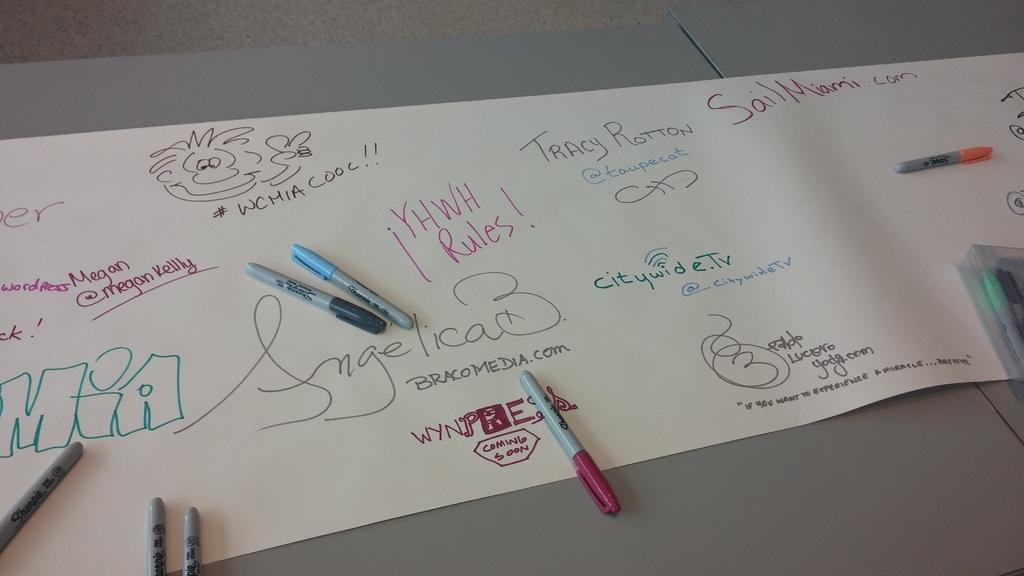What is on the paper in the image? There are markers and drawings on the paper. Can you describe the drawings on the paper? The provided facts do not give specific details about the drawings, so we cannot describe them. What might have been used to create the drawings on the paper? The markers on the paper might have been used to create the drawings. What type of knife is being used to attack the bird in the image? There is no knife or bird present in the image; it only features markers and drawings on the paper. 